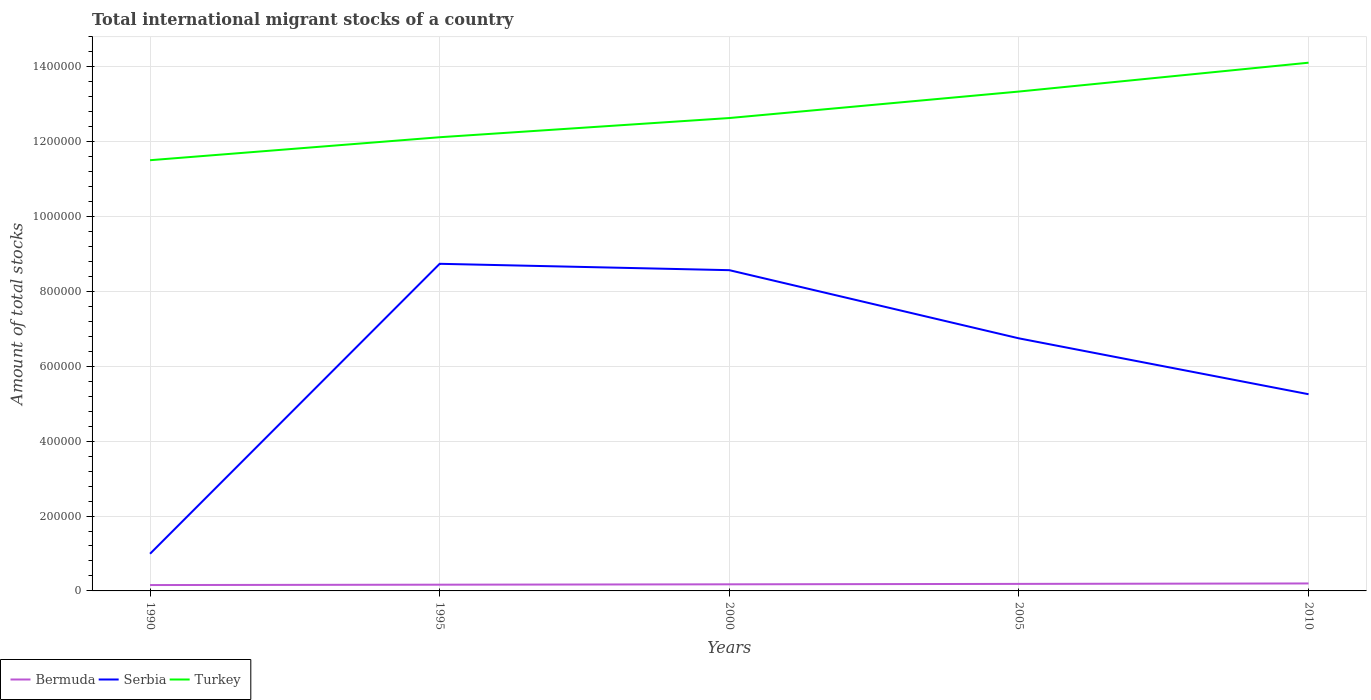Does the line corresponding to Turkey intersect with the line corresponding to Bermuda?
Ensure brevity in your answer.  No. Is the number of lines equal to the number of legend labels?
Provide a succinct answer. Yes. Across all years, what is the maximum amount of total stocks in in Turkey?
Make the answer very short. 1.15e+06. In which year was the amount of total stocks in in Bermuda maximum?
Provide a succinct answer. 1990. What is the total amount of total stocks in in Turkey in the graph?
Provide a short and direct response. -1.48e+05. What is the difference between the highest and the second highest amount of total stocks in in Bermuda?
Offer a very short reply. 4259. What is the difference between the highest and the lowest amount of total stocks in in Turkey?
Your answer should be very brief. 2. Is the amount of total stocks in in Bermuda strictly greater than the amount of total stocks in in Serbia over the years?
Offer a very short reply. Yes. Does the graph contain grids?
Make the answer very short. Yes. What is the title of the graph?
Ensure brevity in your answer.  Total international migrant stocks of a country. Does "Rwanda" appear as one of the legend labels in the graph?
Keep it short and to the point. No. What is the label or title of the X-axis?
Your response must be concise. Years. What is the label or title of the Y-axis?
Give a very brief answer. Amount of total stocks. What is the Amount of total stocks of Bermuda in 1990?
Your answer should be compact. 1.57e+04. What is the Amount of total stocks in Serbia in 1990?
Provide a short and direct response. 9.93e+04. What is the Amount of total stocks of Turkey in 1990?
Provide a short and direct response. 1.15e+06. What is the Amount of total stocks of Bermuda in 1995?
Ensure brevity in your answer.  1.66e+04. What is the Amount of total stocks of Serbia in 1995?
Give a very brief answer. 8.74e+05. What is the Amount of total stocks in Turkey in 1995?
Ensure brevity in your answer.  1.21e+06. What is the Amount of total stocks of Bermuda in 2000?
Provide a short and direct response. 1.77e+04. What is the Amount of total stocks of Serbia in 2000?
Your answer should be very brief. 8.57e+05. What is the Amount of total stocks of Turkey in 2000?
Your answer should be compact. 1.26e+06. What is the Amount of total stocks in Bermuda in 2005?
Make the answer very short. 1.88e+04. What is the Amount of total stocks of Serbia in 2005?
Offer a very short reply. 6.75e+05. What is the Amount of total stocks of Turkey in 2005?
Your answer should be very brief. 1.33e+06. What is the Amount of total stocks in Bermuda in 2010?
Make the answer very short. 1.99e+04. What is the Amount of total stocks in Serbia in 2010?
Provide a succinct answer. 5.25e+05. What is the Amount of total stocks of Turkey in 2010?
Give a very brief answer. 1.41e+06. Across all years, what is the maximum Amount of total stocks in Bermuda?
Offer a terse response. 1.99e+04. Across all years, what is the maximum Amount of total stocks of Serbia?
Ensure brevity in your answer.  8.74e+05. Across all years, what is the maximum Amount of total stocks of Turkey?
Make the answer very short. 1.41e+06. Across all years, what is the minimum Amount of total stocks in Bermuda?
Your answer should be very brief. 1.57e+04. Across all years, what is the minimum Amount of total stocks of Serbia?
Offer a terse response. 9.93e+04. Across all years, what is the minimum Amount of total stocks in Turkey?
Your answer should be very brief. 1.15e+06. What is the total Amount of total stocks of Bermuda in the graph?
Provide a succinct answer. 8.87e+04. What is the total Amount of total stocks in Serbia in the graph?
Provide a short and direct response. 3.03e+06. What is the total Amount of total stocks in Turkey in the graph?
Keep it short and to the point. 6.37e+06. What is the difference between the Amount of total stocks in Bermuda in 1990 and that in 1995?
Provide a short and direct response. -948. What is the difference between the Amount of total stocks of Serbia in 1990 and that in 1995?
Keep it short and to the point. -7.75e+05. What is the difference between the Amount of total stocks in Turkey in 1990 and that in 1995?
Offer a very short reply. -6.14e+04. What is the difference between the Amount of total stocks in Bermuda in 1990 and that in 2000?
Your response must be concise. -1985. What is the difference between the Amount of total stocks of Serbia in 1990 and that in 2000?
Your answer should be compact. -7.57e+05. What is the difference between the Amount of total stocks in Turkey in 1990 and that in 2000?
Your answer should be compact. -1.13e+05. What is the difference between the Amount of total stocks of Bermuda in 1990 and that in 2005?
Your response must be concise. -3088. What is the difference between the Amount of total stocks in Serbia in 1990 and that in 2005?
Your answer should be very brief. -5.75e+05. What is the difference between the Amount of total stocks of Turkey in 1990 and that in 2005?
Your answer should be compact. -1.83e+05. What is the difference between the Amount of total stocks in Bermuda in 1990 and that in 2010?
Offer a terse response. -4259. What is the difference between the Amount of total stocks in Serbia in 1990 and that in 2010?
Your response must be concise. -4.26e+05. What is the difference between the Amount of total stocks in Turkey in 1990 and that in 2010?
Your answer should be compact. -2.60e+05. What is the difference between the Amount of total stocks in Bermuda in 1995 and that in 2000?
Ensure brevity in your answer.  -1037. What is the difference between the Amount of total stocks in Serbia in 1995 and that in 2000?
Offer a very short reply. 1.70e+04. What is the difference between the Amount of total stocks in Turkey in 1995 and that in 2000?
Your response must be concise. -5.13e+04. What is the difference between the Amount of total stocks in Bermuda in 1995 and that in 2005?
Your response must be concise. -2140. What is the difference between the Amount of total stocks of Serbia in 1995 and that in 2005?
Your response must be concise. 1.99e+05. What is the difference between the Amount of total stocks of Turkey in 1995 and that in 2005?
Provide a short and direct response. -1.22e+05. What is the difference between the Amount of total stocks of Bermuda in 1995 and that in 2010?
Your answer should be very brief. -3311. What is the difference between the Amount of total stocks of Serbia in 1995 and that in 2010?
Provide a short and direct response. 3.48e+05. What is the difference between the Amount of total stocks of Turkey in 1995 and that in 2010?
Your answer should be very brief. -1.99e+05. What is the difference between the Amount of total stocks in Bermuda in 2000 and that in 2005?
Your answer should be compact. -1103. What is the difference between the Amount of total stocks in Serbia in 2000 and that in 2005?
Your response must be concise. 1.82e+05. What is the difference between the Amount of total stocks in Turkey in 2000 and that in 2005?
Your answer should be compact. -7.07e+04. What is the difference between the Amount of total stocks in Bermuda in 2000 and that in 2010?
Provide a succinct answer. -2274. What is the difference between the Amount of total stocks in Serbia in 2000 and that in 2010?
Provide a short and direct response. 3.31e+05. What is the difference between the Amount of total stocks of Turkey in 2000 and that in 2010?
Your answer should be very brief. -1.48e+05. What is the difference between the Amount of total stocks in Bermuda in 2005 and that in 2010?
Offer a terse response. -1171. What is the difference between the Amount of total stocks of Serbia in 2005 and that in 2010?
Keep it short and to the point. 1.49e+05. What is the difference between the Amount of total stocks of Turkey in 2005 and that in 2010?
Keep it short and to the point. -7.71e+04. What is the difference between the Amount of total stocks in Bermuda in 1990 and the Amount of total stocks in Serbia in 1995?
Give a very brief answer. -8.58e+05. What is the difference between the Amount of total stocks in Bermuda in 1990 and the Amount of total stocks in Turkey in 1995?
Provide a succinct answer. -1.20e+06. What is the difference between the Amount of total stocks in Serbia in 1990 and the Amount of total stocks in Turkey in 1995?
Provide a succinct answer. -1.11e+06. What is the difference between the Amount of total stocks of Bermuda in 1990 and the Amount of total stocks of Serbia in 2000?
Offer a very short reply. -8.41e+05. What is the difference between the Amount of total stocks of Bermuda in 1990 and the Amount of total stocks of Turkey in 2000?
Offer a terse response. -1.25e+06. What is the difference between the Amount of total stocks of Serbia in 1990 and the Amount of total stocks of Turkey in 2000?
Your answer should be very brief. -1.16e+06. What is the difference between the Amount of total stocks in Bermuda in 1990 and the Amount of total stocks in Serbia in 2005?
Give a very brief answer. -6.59e+05. What is the difference between the Amount of total stocks of Bermuda in 1990 and the Amount of total stocks of Turkey in 2005?
Your answer should be very brief. -1.32e+06. What is the difference between the Amount of total stocks of Serbia in 1990 and the Amount of total stocks of Turkey in 2005?
Offer a very short reply. -1.23e+06. What is the difference between the Amount of total stocks of Bermuda in 1990 and the Amount of total stocks of Serbia in 2010?
Make the answer very short. -5.10e+05. What is the difference between the Amount of total stocks of Bermuda in 1990 and the Amount of total stocks of Turkey in 2010?
Give a very brief answer. -1.40e+06. What is the difference between the Amount of total stocks of Serbia in 1990 and the Amount of total stocks of Turkey in 2010?
Your answer should be very brief. -1.31e+06. What is the difference between the Amount of total stocks in Bermuda in 1995 and the Amount of total stocks in Serbia in 2000?
Give a very brief answer. -8.40e+05. What is the difference between the Amount of total stocks of Bermuda in 1995 and the Amount of total stocks of Turkey in 2000?
Provide a short and direct response. -1.25e+06. What is the difference between the Amount of total stocks in Serbia in 1995 and the Amount of total stocks in Turkey in 2000?
Provide a short and direct response. -3.89e+05. What is the difference between the Amount of total stocks in Bermuda in 1995 and the Amount of total stocks in Serbia in 2005?
Keep it short and to the point. -6.58e+05. What is the difference between the Amount of total stocks of Bermuda in 1995 and the Amount of total stocks of Turkey in 2005?
Your answer should be very brief. -1.32e+06. What is the difference between the Amount of total stocks of Serbia in 1995 and the Amount of total stocks of Turkey in 2005?
Give a very brief answer. -4.60e+05. What is the difference between the Amount of total stocks in Bermuda in 1995 and the Amount of total stocks in Serbia in 2010?
Ensure brevity in your answer.  -5.09e+05. What is the difference between the Amount of total stocks of Bermuda in 1995 and the Amount of total stocks of Turkey in 2010?
Your response must be concise. -1.39e+06. What is the difference between the Amount of total stocks of Serbia in 1995 and the Amount of total stocks of Turkey in 2010?
Offer a terse response. -5.37e+05. What is the difference between the Amount of total stocks in Bermuda in 2000 and the Amount of total stocks in Serbia in 2005?
Give a very brief answer. -6.57e+05. What is the difference between the Amount of total stocks in Bermuda in 2000 and the Amount of total stocks in Turkey in 2005?
Provide a short and direct response. -1.32e+06. What is the difference between the Amount of total stocks of Serbia in 2000 and the Amount of total stocks of Turkey in 2005?
Provide a short and direct response. -4.77e+05. What is the difference between the Amount of total stocks in Bermuda in 2000 and the Amount of total stocks in Serbia in 2010?
Offer a very short reply. -5.08e+05. What is the difference between the Amount of total stocks of Bermuda in 2000 and the Amount of total stocks of Turkey in 2010?
Make the answer very short. -1.39e+06. What is the difference between the Amount of total stocks of Serbia in 2000 and the Amount of total stocks of Turkey in 2010?
Provide a succinct answer. -5.54e+05. What is the difference between the Amount of total stocks of Bermuda in 2005 and the Amount of total stocks of Serbia in 2010?
Offer a very short reply. -5.07e+05. What is the difference between the Amount of total stocks of Bermuda in 2005 and the Amount of total stocks of Turkey in 2010?
Make the answer very short. -1.39e+06. What is the difference between the Amount of total stocks in Serbia in 2005 and the Amount of total stocks in Turkey in 2010?
Give a very brief answer. -7.36e+05. What is the average Amount of total stocks of Bermuda per year?
Offer a terse response. 1.77e+04. What is the average Amount of total stocks of Serbia per year?
Offer a very short reply. 6.06e+05. What is the average Amount of total stocks in Turkey per year?
Make the answer very short. 1.27e+06. In the year 1990, what is the difference between the Amount of total stocks of Bermuda and Amount of total stocks of Serbia?
Your response must be concise. -8.36e+04. In the year 1990, what is the difference between the Amount of total stocks of Bermuda and Amount of total stocks of Turkey?
Your answer should be compact. -1.13e+06. In the year 1990, what is the difference between the Amount of total stocks of Serbia and Amount of total stocks of Turkey?
Your response must be concise. -1.05e+06. In the year 1995, what is the difference between the Amount of total stocks in Bermuda and Amount of total stocks in Serbia?
Provide a short and direct response. -8.57e+05. In the year 1995, what is the difference between the Amount of total stocks in Bermuda and Amount of total stocks in Turkey?
Keep it short and to the point. -1.20e+06. In the year 1995, what is the difference between the Amount of total stocks in Serbia and Amount of total stocks in Turkey?
Your answer should be compact. -3.38e+05. In the year 2000, what is the difference between the Amount of total stocks of Bermuda and Amount of total stocks of Serbia?
Your answer should be compact. -8.39e+05. In the year 2000, what is the difference between the Amount of total stocks of Bermuda and Amount of total stocks of Turkey?
Offer a very short reply. -1.25e+06. In the year 2000, what is the difference between the Amount of total stocks in Serbia and Amount of total stocks in Turkey?
Your answer should be compact. -4.06e+05. In the year 2005, what is the difference between the Amount of total stocks of Bermuda and Amount of total stocks of Serbia?
Give a very brief answer. -6.56e+05. In the year 2005, what is the difference between the Amount of total stocks in Bermuda and Amount of total stocks in Turkey?
Keep it short and to the point. -1.32e+06. In the year 2005, what is the difference between the Amount of total stocks of Serbia and Amount of total stocks of Turkey?
Offer a terse response. -6.59e+05. In the year 2010, what is the difference between the Amount of total stocks in Bermuda and Amount of total stocks in Serbia?
Give a very brief answer. -5.05e+05. In the year 2010, what is the difference between the Amount of total stocks of Bermuda and Amount of total stocks of Turkey?
Your answer should be compact. -1.39e+06. In the year 2010, what is the difference between the Amount of total stocks of Serbia and Amount of total stocks of Turkey?
Provide a succinct answer. -8.86e+05. What is the ratio of the Amount of total stocks in Bermuda in 1990 to that in 1995?
Your answer should be very brief. 0.94. What is the ratio of the Amount of total stocks in Serbia in 1990 to that in 1995?
Your answer should be compact. 0.11. What is the ratio of the Amount of total stocks in Turkey in 1990 to that in 1995?
Make the answer very short. 0.95. What is the ratio of the Amount of total stocks of Bermuda in 1990 to that in 2000?
Give a very brief answer. 0.89. What is the ratio of the Amount of total stocks of Serbia in 1990 to that in 2000?
Give a very brief answer. 0.12. What is the ratio of the Amount of total stocks of Turkey in 1990 to that in 2000?
Your answer should be compact. 0.91. What is the ratio of the Amount of total stocks in Bermuda in 1990 to that in 2005?
Offer a terse response. 0.84. What is the ratio of the Amount of total stocks of Serbia in 1990 to that in 2005?
Your answer should be very brief. 0.15. What is the ratio of the Amount of total stocks of Turkey in 1990 to that in 2005?
Offer a terse response. 0.86. What is the ratio of the Amount of total stocks of Bermuda in 1990 to that in 2010?
Ensure brevity in your answer.  0.79. What is the ratio of the Amount of total stocks in Serbia in 1990 to that in 2010?
Your answer should be compact. 0.19. What is the ratio of the Amount of total stocks in Turkey in 1990 to that in 2010?
Offer a terse response. 0.82. What is the ratio of the Amount of total stocks in Bermuda in 1995 to that in 2000?
Ensure brevity in your answer.  0.94. What is the ratio of the Amount of total stocks of Serbia in 1995 to that in 2000?
Ensure brevity in your answer.  1.02. What is the ratio of the Amount of total stocks of Turkey in 1995 to that in 2000?
Offer a very short reply. 0.96. What is the ratio of the Amount of total stocks of Bermuda in 1995 to that in 2005?
Your answer should be very brief. 0.89. What is the ratio of the Amount of total stocks of Serbia in 1995 to that in 2005?
Provide a short and direct response. 1.3. What is the ratio of the Amount of total stocks in Turkey in 1995 to that in 2005?
Provide a short and direct response. 0.91. What is the ratio of the Amount of total stocks of Bermuda in 1995 to that in 2010?
Provide a short and direct response. 0.83. What is the ratio of the Amount of total stocks in Serbia in 1995 to that in 2010?
Keep it short and to the point. 1.66. What is the ratio of the Amount of total stocks in Turkey in 1995 to that in 2010?
Give a very brief answer. 0.86. What is the ratio of the Amount of total stocks in Serbia in 2000 to that in 2005?
Your response must be concise. 1.27. What is the ratio of the Amount of total stocks in Turkey in 2000 to that in 2005?
Your answer should be compact. 0.95. What is the ratio of the Amount of total stocks in Bermuda in 2000 to that in 2010?
Your response must be concise. 0.89. What is the ratio of the Amount of total stocks in Serbia in 2000 to that in 2010?
Your response must be concise. 1.63. What is the ratio of the Amount of total stocks of Turkey in 2000 to that in 2010?
Your answer should be very brief. 0.9. What is the ratio of the Amount of total stocks in Bermuda in 2005 to that in 2010?
Make the answer very short. 0.94. What is the ratio of the Amount of total stocks of Serbia in 2005 to that in 2010?
Offer a very short reply. 1.28. What is the ratio of the Amount of total stocks of Turkey in 2005 to that in 2010?
Provide a succinct answer. 0.95. What is the difference between the highest and the second highest Amount of total stocks of Bermuda?
Keep it short and to the point. 1171. What is the difference between the highest and the second highest Amount of total stocks of Serbia?
Keep it short and to the point. 1.70e+04. What is the difference between the highest and the second highest Amount of total stocks of Turkey?
Ensure brevity in your answer.  7.71e+04. What is the difference between the highest and the lowest Amount of total stocks in Bermuda?
Offer a terse response. 4259. What is the difference between the highest and the lowest Amount of total stocks of Serbia?
Keep it short and to the point. 7.75e+05. What is the difference between the highest and the lowest Amount of total stocks in Turkey?
Your response must be concise. 2.60e+05. 